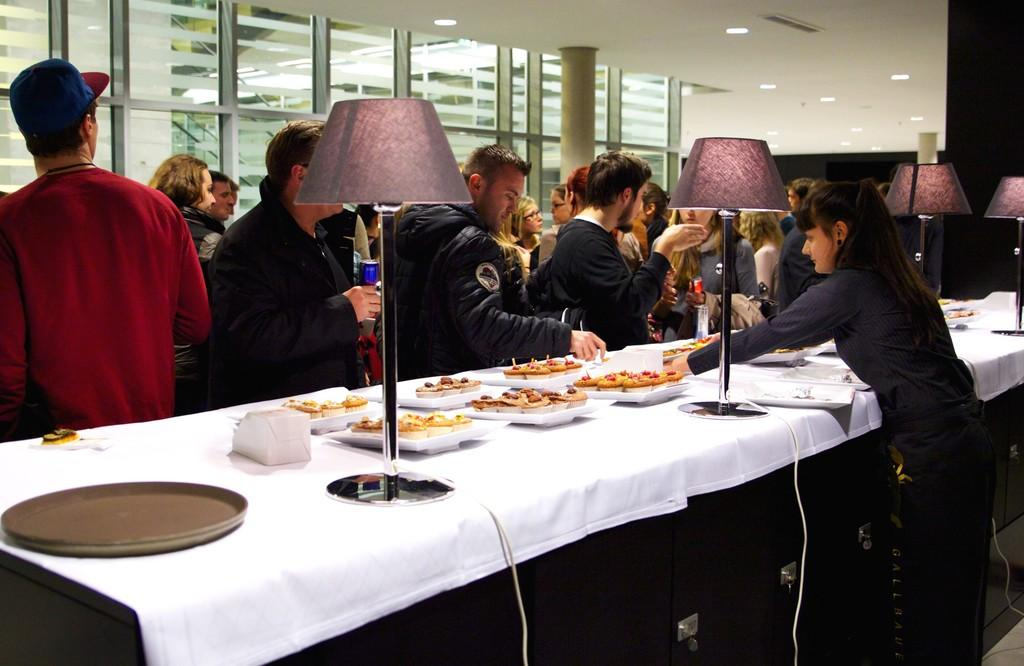How many people are in the image? There is a group of people in the image. What are the people doing in the image? The people are standing in front of a table. What is on the table in the image? The table has plates of food on it. Who is serving the food in the image? A woman is serving the food. What else can be seen on the table in the image? There are lamps placed on the table. What type of song is being played in the background of the image? There is no information about any song being played in the background of the image. 